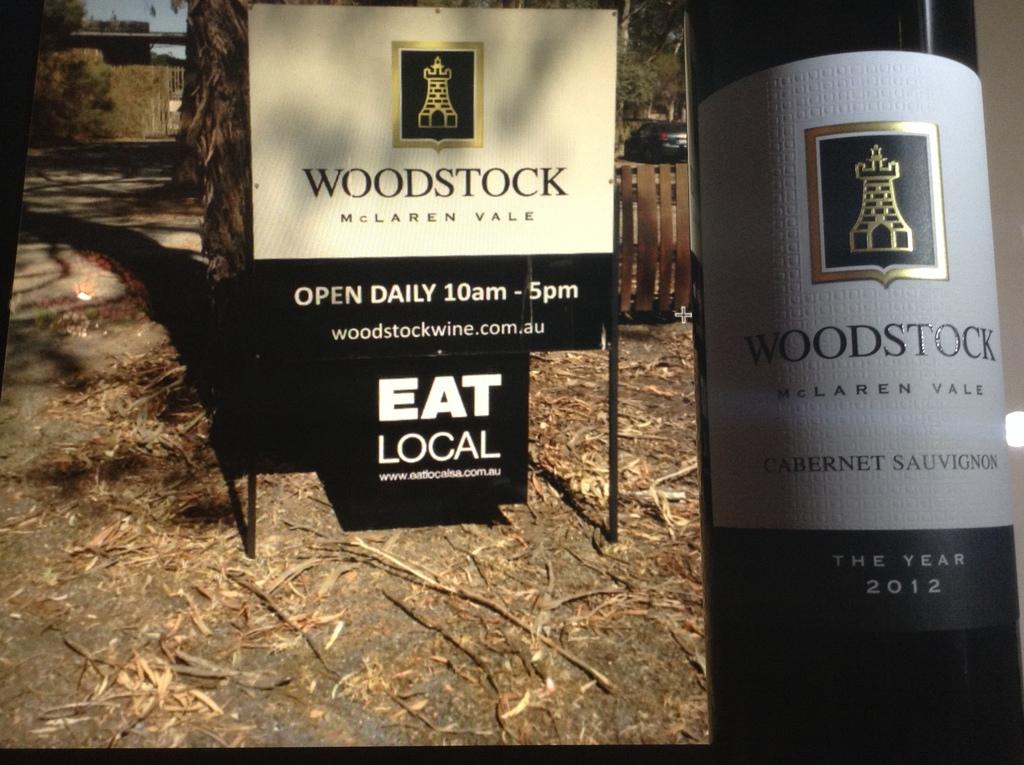When is woodstock open?
Your answer should be compact. 10am. 